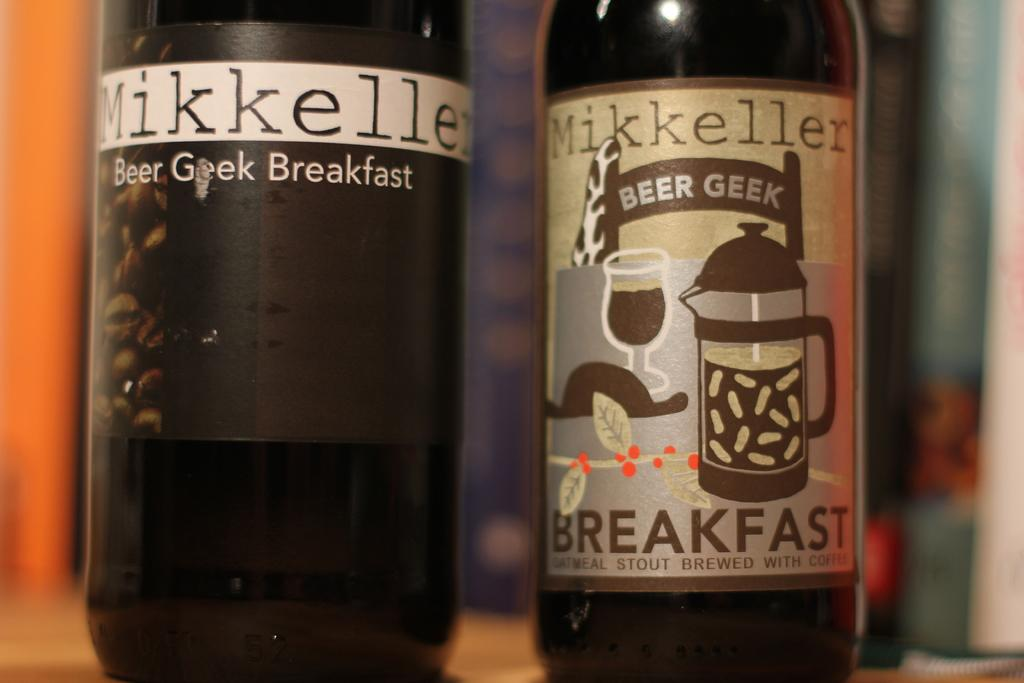<image>
Give a short and clear explanation of the subsequent image. Two different bottles of Mikkeller beer are side by side, with their labels facing forward. 